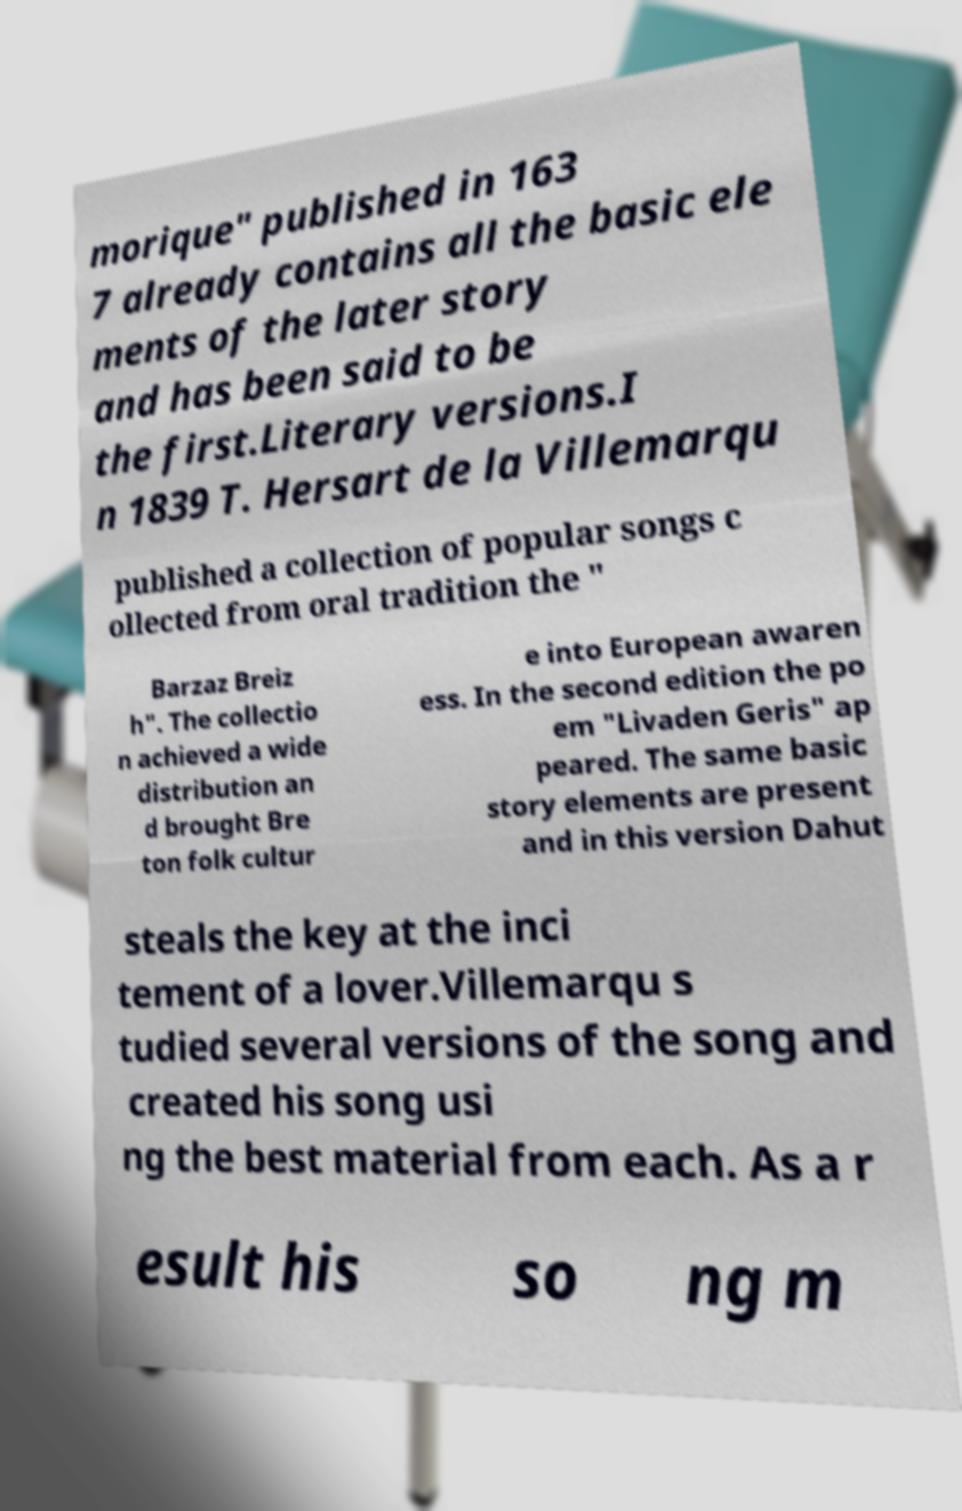Can you read and provide the text displayed in the image?This photo seems to have some interesting text. Can you extract and type it out for me? morique" published in 163 7 already contains all the basic ele ments of the later story and has been said to be the first.Literary versions.I n 1839 T. Hersart de la Villemarqu published a collection of popular songs c ollected from oral tradition the " Barzaz Breiz h". The collectio n achieved a wide distribution an d brought Bre ton folk cultur e into European awaren ess. In the second edition the po em "Livaden Geris" ap peared. The same basic story elements are present and in this version Dahut steals the key at the inci tement of a lover.Villemarqu s tudied several versions of the song and created his song usi ng the best material from each. As a r esult his so ng m 